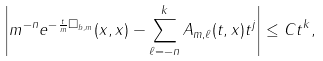<formula> <loc_0><loc_0><loc_500><loc_500>\left | m ^ { - n } e ^ { - \frac { t } { m } \Box _ { b , m } } ( x , x ) - \sum _ { \ell = - n } ^ { k } A _ { m , \ell } ( t , x ) t ^ { j } \right | \leq C t ^ { k } ,</formula> 